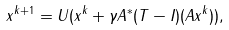Convert formula to latex. <formula><loc_0><loc_0><loc_500><loc_500>x ^ { k + 1 } = U ( x ^ { k } + \gamma A ^ { \ast } ( T - I ) ( A x ^ { k } ) ) ,</formula> 